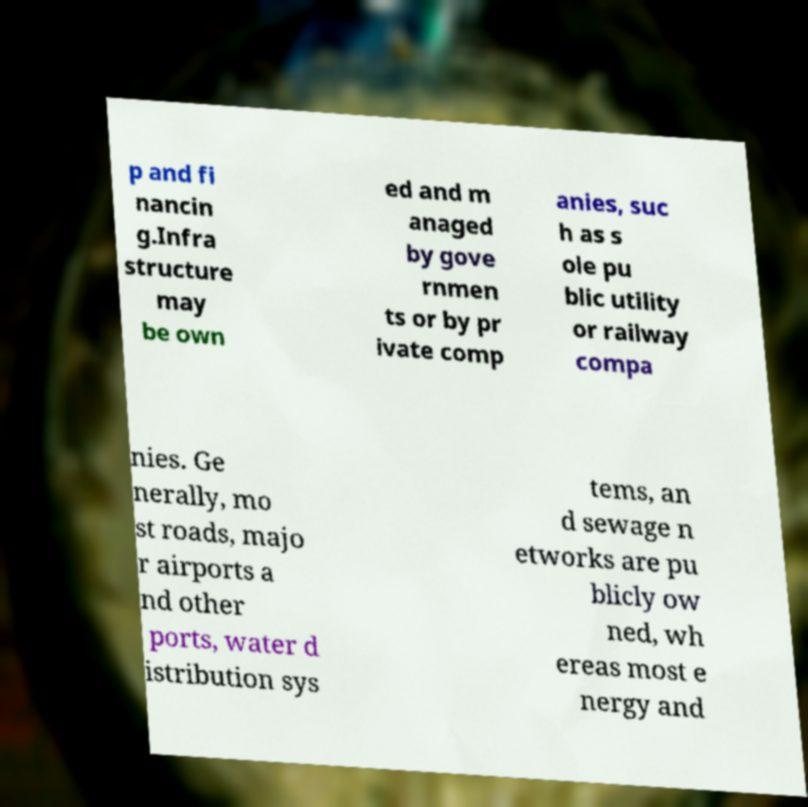For documentation purposes, I need the text within this image transcribed. Could you provide that? p and fi nancin g.Infra structure may be own ed and m anaged by gove rnmen ts or by pr ivate comp anies, suc h as s ole pu blic utility or railway compa nies. Ge nerally, mo st roads, majo r airports a nd other ports, water d istribution sys tems, an d sewage n etworks are pu blicly ow ned, wh ereas most e nergy and 